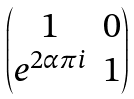<formula> <loc_0><loc_0><loc_500><loc_500>\begin{pmatrix} 1 & 0 \\ e ^ { 2 \alpha \pi i } & 1 \end{pmatrix}</formula> 